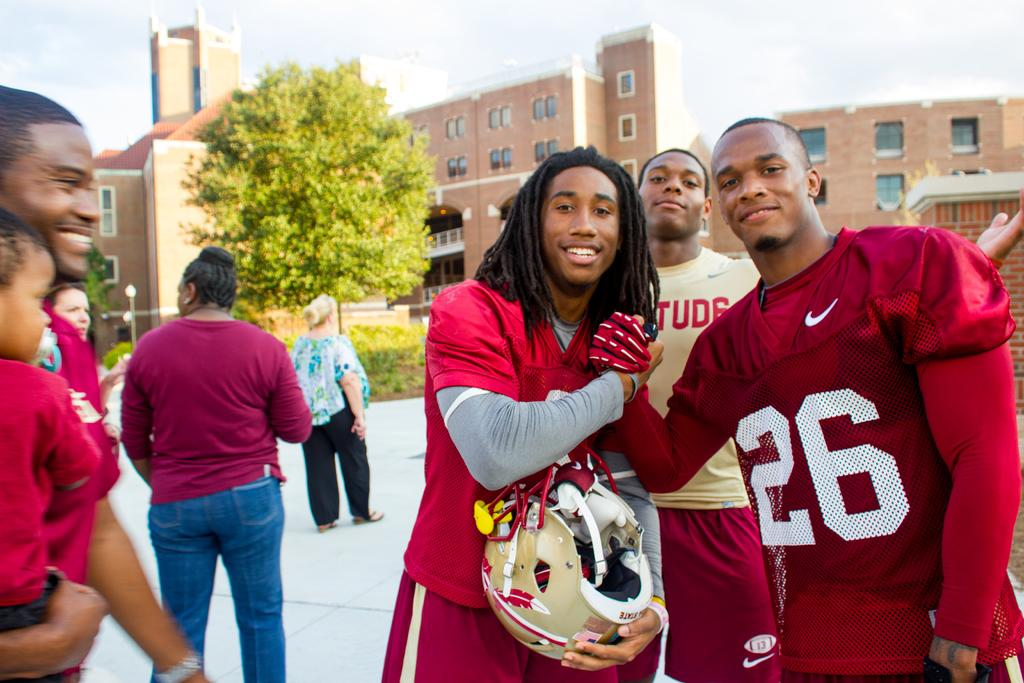<image>
Give a short and clear explanation of the subsequent image. Two African American college males wear red football uniforms as they grasp hands and smile with a backdrop of college dorms and random people milling about.. 